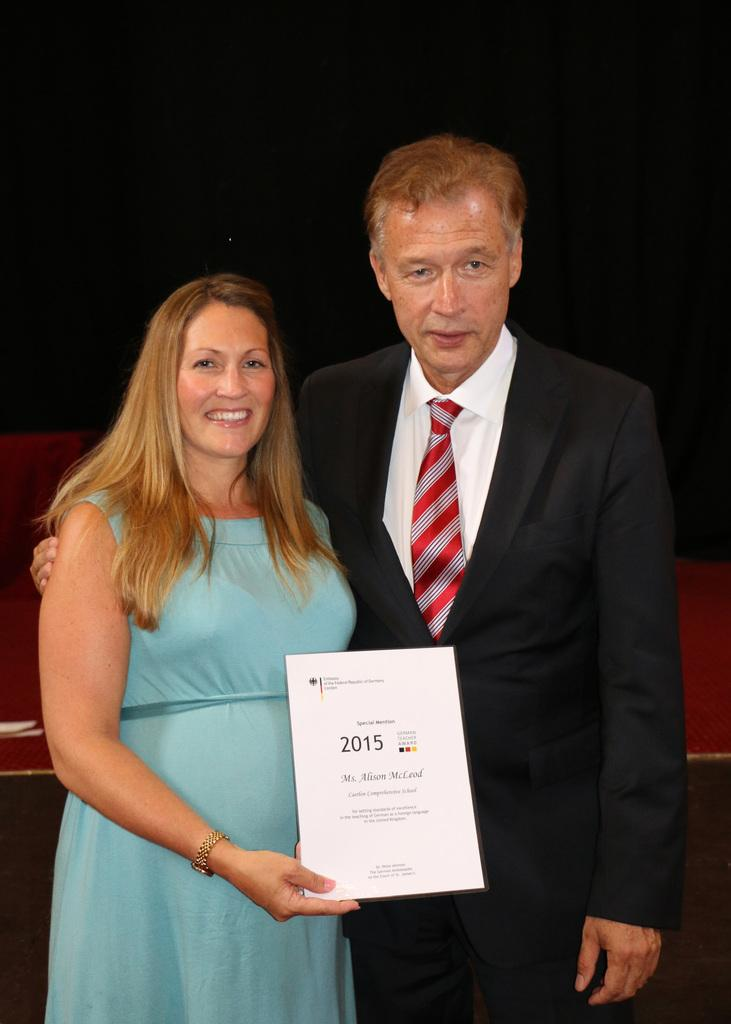How many people are in the image? There are two people in the image, a woman and a man. What are the expressions on their faces? Both the woman and the man are smiling in the image. What can be observed about the lighting in the image? The background of the image is dark. How many cars are visible in the image? There are no cars present in the image. What is the woman starting in the image? There is no indication in the image that the woman is starting anything. 